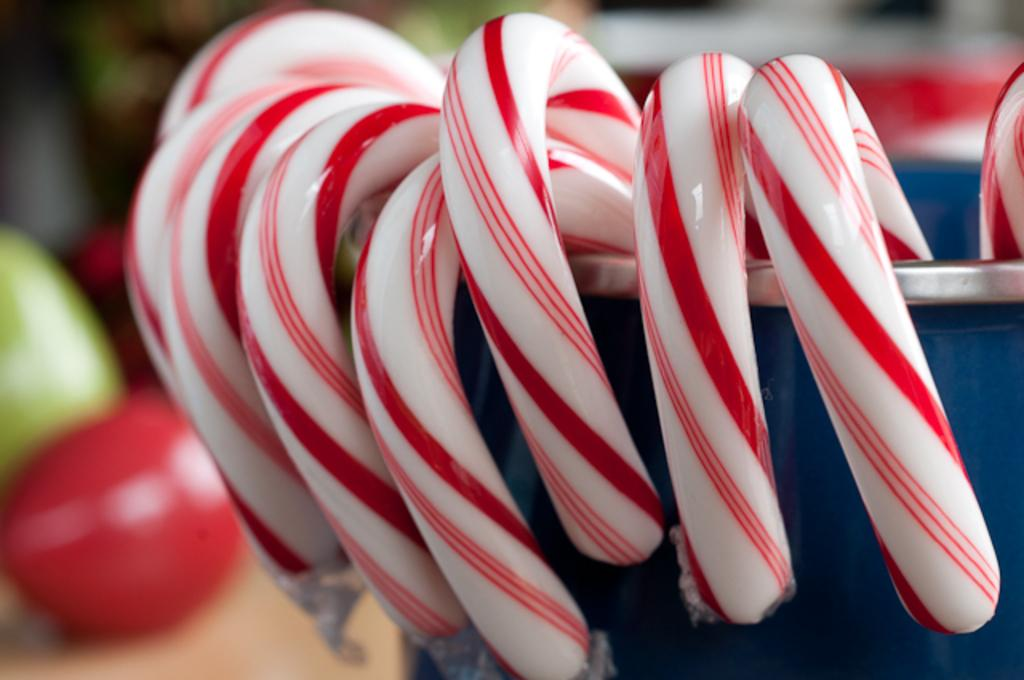What type of sweets are present in the image? There are candies in the image. Where are the candies located? The candies are on a blue container. Can you describe anything else visible on the left side of the image? There might be balls visible on the left side of the image. What type of worm can be seen crawling on the blue container in the image? There is no worm present in the image; it only features candies on a blue container and possibly balls on the left side. 